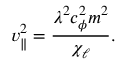Convert formula to latex. <formula><loc_0><loc_0><loc_500><loc_500>v _ { \| } ^ { 2 } = \frac { \lambda ^ { 2 } c _ { \phi } ^ { 2 } m ^ { 2 } } { \chi _ { \ell } } .</formula> 